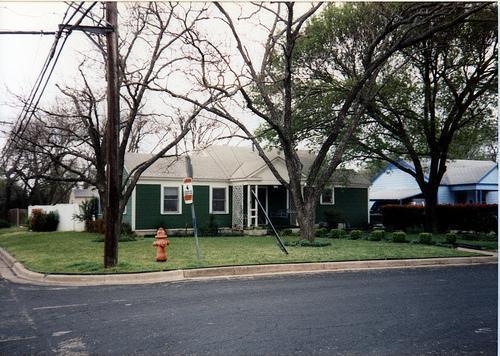How many houses is in this picture?
Give a very brief answer. 2. 